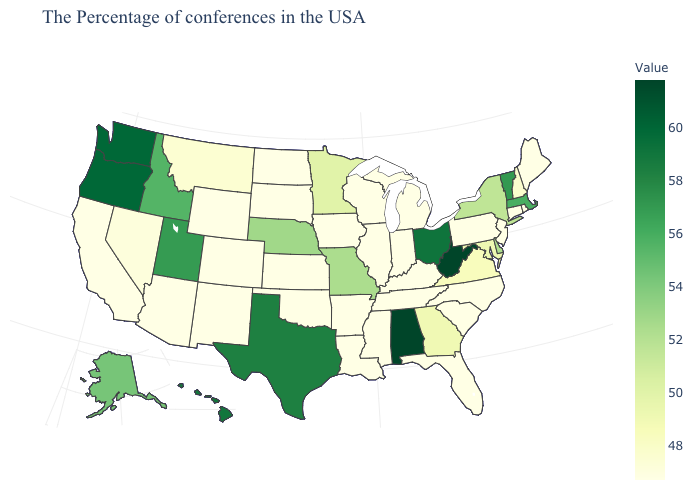Does Oregon have the highest value in the West?
Quick response, please. Yes. Among the states that border Virginia , which have the highest value?
Give a very brief answer. West Virginia. Among the states that border Missouri , which have the lowest value?
Give a very brief answer. Kentucky, Tennessee, Illinois, Arkansas, Iowa, Kansas, Oklahoma. Which states hav the highest value in the West?
Be succinct. Washington, Oregon. Does Maryland have the highest value in the South?
Short answer required. No. Which states have the highest value in the USA?
Write a very short answer. West Virginia, Alabama. Among the states that border New Jersey , does Pennsylvania have the highest value?
Write a very short answer. No. 